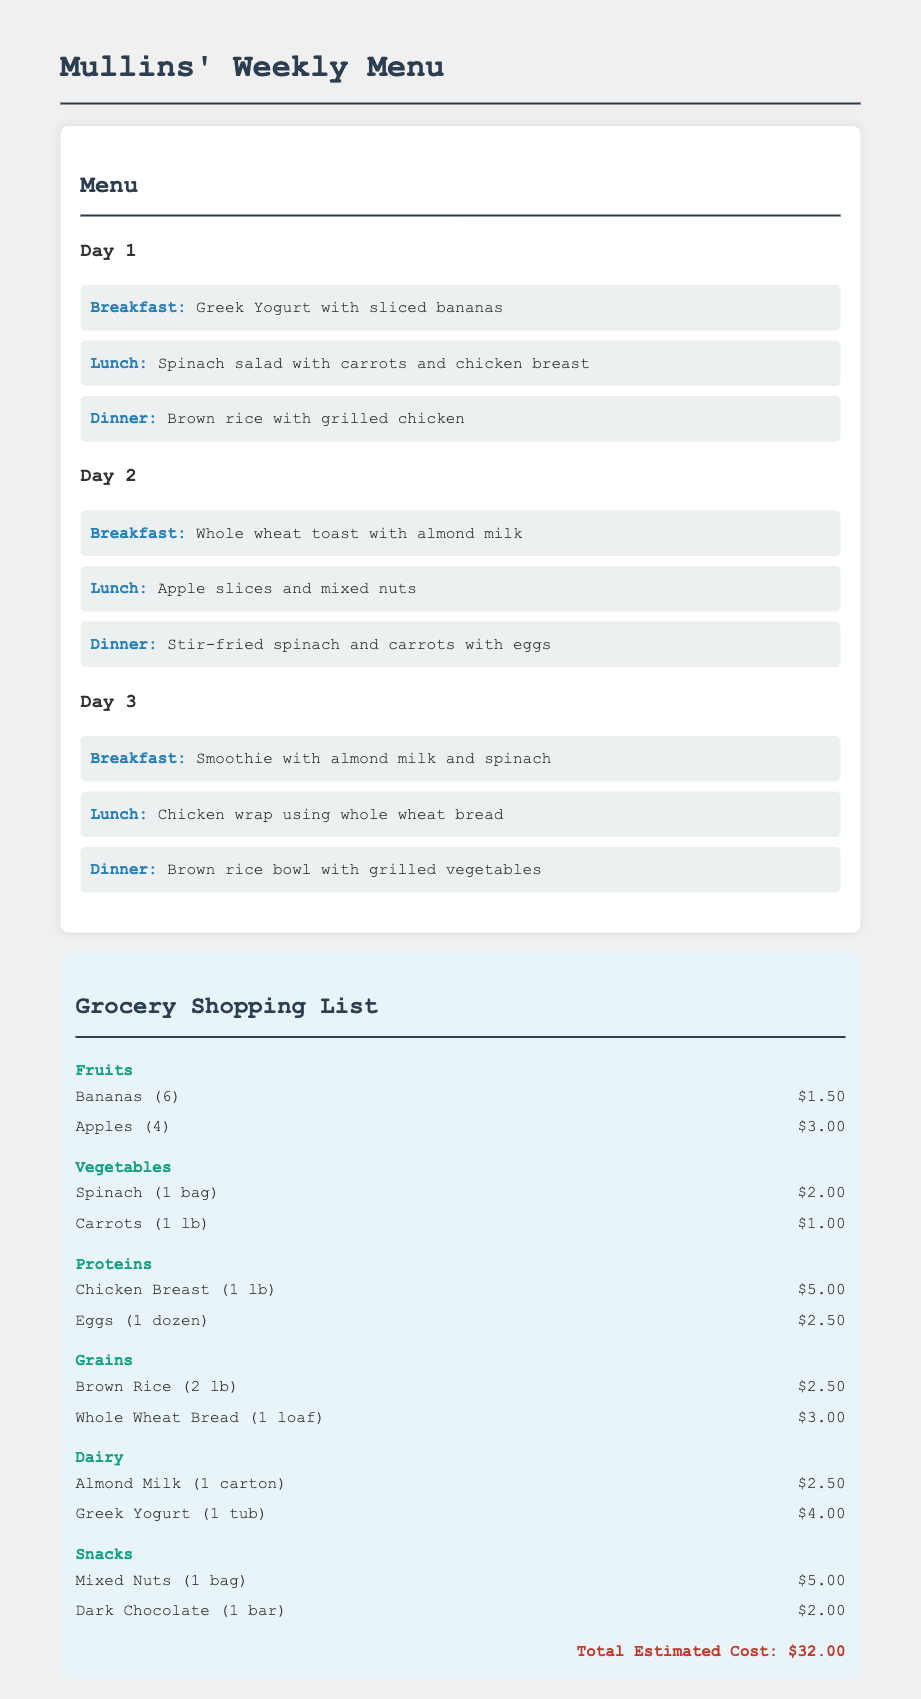What is the total estimated cost? The total estimated cost is mentioned at the bottom of the shopping list section, which is the sum of all food items listed.
Answer: $32.00 How many apples are included in the shopping list? The number of apples is specified in the fruits category of the shopping list.
Answer: 4 What type of bread is listed in the grocery shopping list? The type of bread is described under the grains category in the shopping list.
Answer: Whole Wheat Bread How many meals are planned for Day 2? The number of meals is determined by counting the meals listed for Day 2 in the menu section.
Answer: 3 What protein source is listed for breakfast on Day 3? The breakfast meal for Day 3 does not specify a protein source; however, it mentions ingredients that may include protein.
Answer: None What vegetable is included in the shopping list? The vegetables are specified under the vegetables category in the shopping list.
Answer: Spinach How many items are listed under snacks? The number of snack items is counted from the snacks category in the grocery shopping list.
Answer: 2 What is the first item listed under fruits? The first item is identified from the fruits category in the shopping list.
Answer: Bananas (6) 